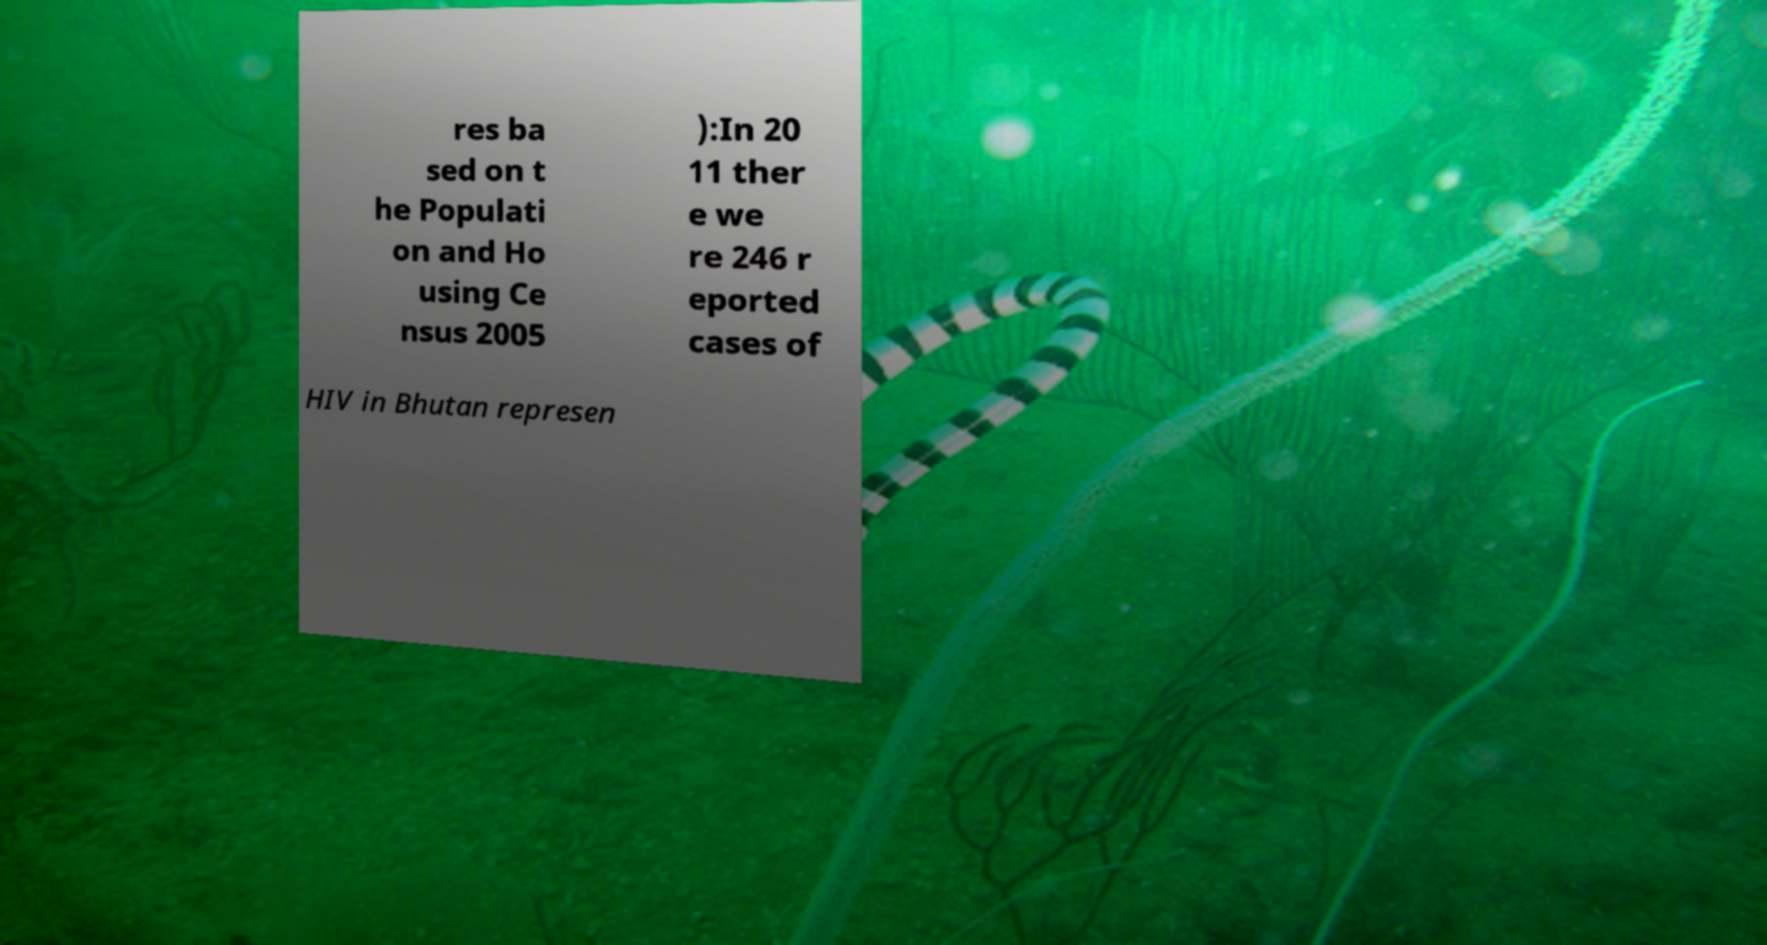Could you assist in decoding the text presented in this image and type it out clearly? res ba sed on t he Populati on and Ho using Ce nsus 2005 ):In 20 11 ther e we re 246 r eported cases of HIV in Bhutan represen 